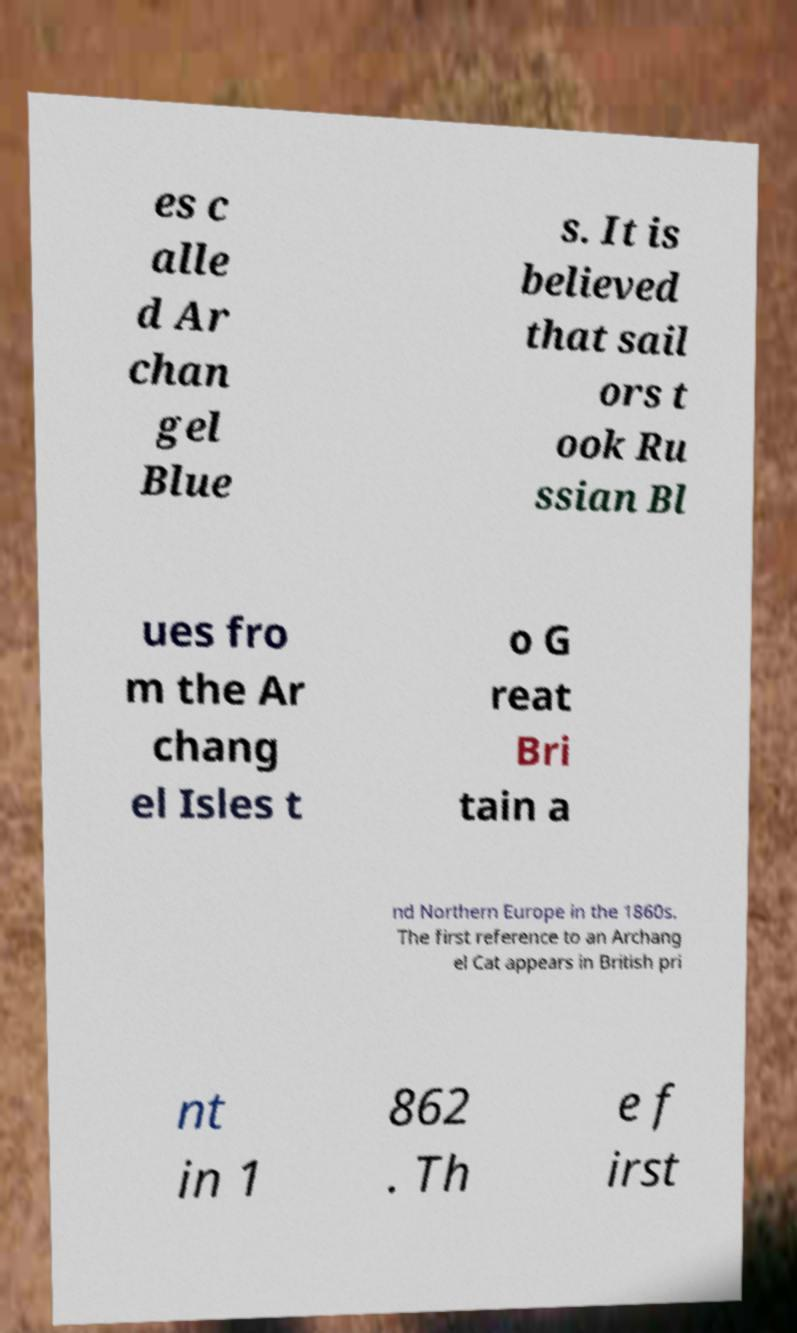Please read and relay the text visible in this image. What does it say? es c alle d Ar chan gel Blue s. It is believed that sail ors t ook Ru ssian Bl ues fro m the Ar chang el Isles t o G reat Bri tain a nd Northern Europe in the 1860s. The first reference to an Archang el Cat appears in British pri nt in 1 862 . Th e f irst 